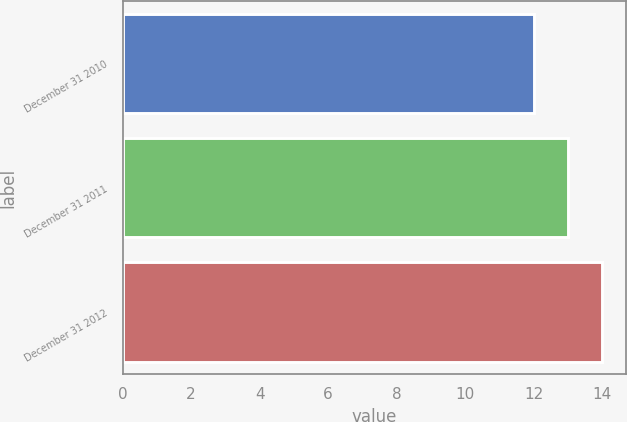Convert chart. <chart><loc_0><loc_0><loc_500><loc_500><bar_chart><fcel>December 31 2010<fcel>December 31 2011<fcel>December 31 2012<nl><fcel>12<fcel>13<fcel>14<nl></chart> 